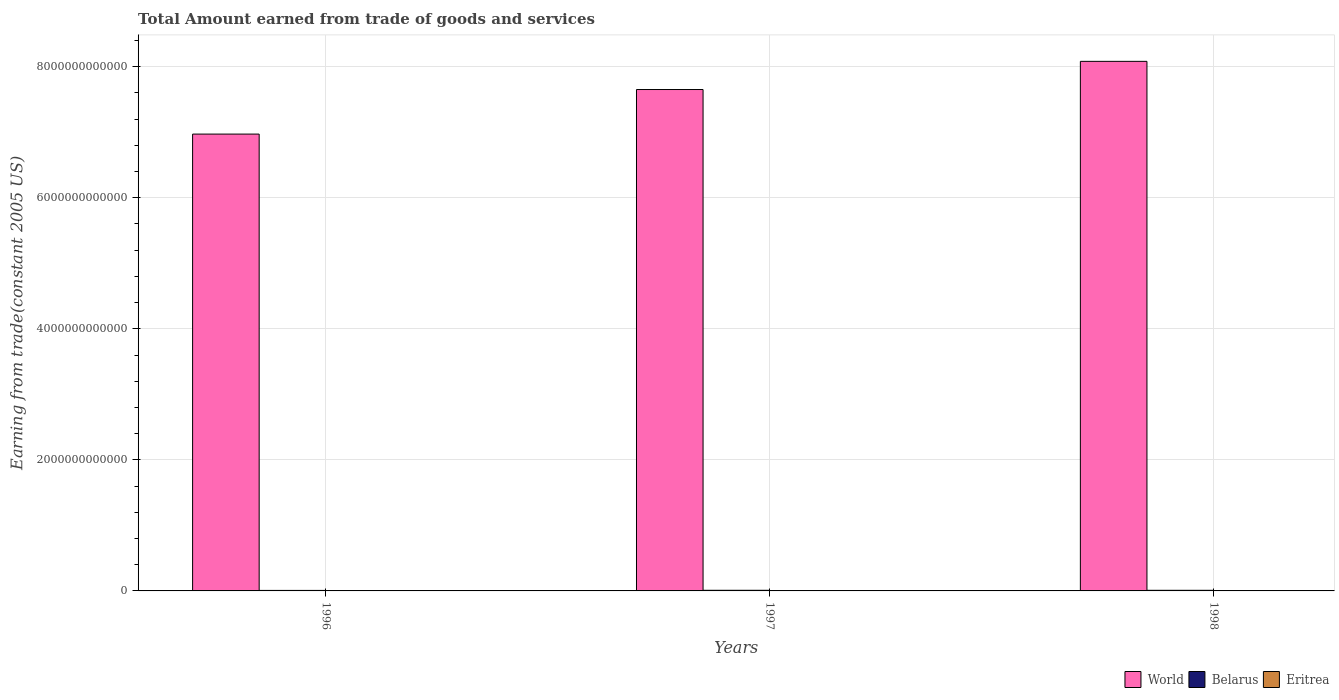How many different coloured bars are there?
Provide a short and direct response. 3. How many groups of bars are there?
Your answer should be compact. 3. Are the number of bars on each tick of the X-axis equal?
Ensure brevity in your answer.  Yes. How many bars are there on the 3rd tick from the left?
Offer a terse response. 3. How many bars are there on the 1st tick from the right?
Give a very brief answer. 3. What is the total amount earned by trading goods and services in Eritrea in 1998?
Offer a very short reply. 8.29e+08. Across all years, what is the maximum total amount earned by trading goods and services in Eritrea?
Your answer should be very brief. 8.29e+08. Across all years, what is the minimum total amount earned by trading goods and services in Belarus?
Your answer should be very brief. 7.64e+09. What is the total total amount earned by trading goods and services in Belarus in the graph?
Offer a terse response. 2.68e+1. What is the difference between the total amount earned by trading goods and services in Belarus in 1996 and that in 1998?
Make the answer very short. -1.84e+09. What is the difference between the total amount earned by trading goods and services in Belarus in 1997 and the total amount earned by trading goods and services in Eritrea in 1996?
Keep it short and to the point. 8.90e+09. What is the average total amount earned by trading goods and services in World per year?
Offer a very short reply. 7.57e+12. In the year 1997, what is the difference between the total amount earned by trading goods and services in World and total amount earned by trading goods and services in Belarus?
Your answer should be very brief. 7.64e+12. What is the ratio of the total amount earned by trading goods and services in World in 1997 to that in 1998?
Offer a very short reply. 0.95. Is the difference between the total amount earned by trading goods and services in World in 1997 and 1998 greater than the difference between the total amount earned by trading goods and services in Belarus in 1997 and 1998?
Offer a very short reply. No. What is the difference between the highest and the second highest total amount earned by trading goods and services in Belarus?
Provide a succinct answer. 1.84e+08. What is the difference between the highest and the lowest total amount earned by trading goods and services in Eritrea?
Provide a succinct answer. 6.05e+07. In how many years, is the total amount earned by trading goods and services in World greater than the average total amount earned by trading goods and services in World taken over all years?
Make the answer very short. 2. What does the 1st bar from the left in 1997 represents?
Give a very brief answer. World. What does the 2nd bar from the right in 1998 represents?
Provide a succinct answer. Belarus. Is it the case that in every year, the sum of the total amount earned by trading goods and services in Eritrea and total amount earned by trading goods and services in World is greater than the total amount earned by trading goods and services in Belarus?
Offer a very short reply. Yes. What is the difference between two consecutive major ticks on the Y-axis?
Your response must be concise. 2.00e+12. Does the graph contain any zero values?
Ensure brevity in your answer.  No. How are the legend labels stacked?
Provide a succinct answer. Horizontal. What is the title of the graph?
Provide a short and direct response. Total Amount earned from trade of goods and services. What is the label or title of the Y-axis?
Offer a very short reply. Earning from trade(constant 2005 US). What is the Earning from trade(constant 2005 US) of World in 1996?
Ensure brevity in your answer.  6.97e+12. What is the Earning from trade(constant 2005 US) of Belarus in 1996?
Your answer should be very brief. 7.64e+09. What is the Earning from trade(constant 2005 US) in Eritrea in 1996?
Provide a short and direct response. 7.69e+08. What is the Earning from trade(constant 2005 US) in World in 1997?
Offer a very short reply. 7.65e+12. What is the Earning from trade(constant 2005 US) in Belarus in 1997?
Ensure brevity in your answer.  9.66e+09. What is the Earning from trade(constant 2005 US) of Eritrea in 1997?
Keep it short and to the point. 7.87e+08. What is the Earning from trade(constant 2005 US) of World in 1998?
Offer a terse response. 8.08e+12. What is the Earning from trade(constant 2005 US) of Belarus in 1998?
Provide a short and direct response. 9.48e+09. What is the Earning from trade(constant 2005 US) of Eritrea in 1998?
Give a very brief answer. 8.29e+08. Across all years, what is the maximum Earning from trade(constant 2005 US) in World?
Offer a very short reply. 8.08e+12. Across all years, what is the maximum Earning from trade(constant 2005 US) in Belarus?
Provide a short and direct response. 9.66e+09. Across all years, what is the maximum Earning from trade(constant 2005 US) of Eritrea?
Your answer should be compact. 8.29e+08. Across all years, what is the minimum Earning from trade(constant 2005 US) of World?
Keep it short and to the point. 6.97e+12. Across all years, what is the minimum Earning from trade(constant 2005 US) of Belarus?
Give a very brief answer. 7.64e+09. Across all years, what is the minimum Earning from trade(constant 2005 US) of Eritrea?
Ensure brevity in your answer.  7.69e+08. What is the total Earning from trade(constant 2005 US) in World in the graph?
Give a very brief answer. 2.27e+13. What is the total Earning from trade(constant 2005 US) of Belarus in the graph?
Provide a succinct answer. 2.68e+1. What is the total Earning from trade(constant 2005 US) in Eritrea in the graph?
Provide a short and direct response. 2.39e+09. What is the difference between the Earning from trade(constant 2005 US) of World in 1996 and that in 1997?
Offer a very short reply. -6.80e+11. What is the difference between the Earning from trade(constant 2005 US) in Belarus in 1996 and that in 1997?
Ensure brevity in your answer.  -2.02e+09. What is the difference between the Earning from trade(constant 2005 US) of Eritrea in 1996 and that in 1997?
Your answer should be very brief. -1.86e+07. What is the difference between the Earning from trade(constant 2005 US) in World in 1996 and that in 1998?
Give a very brief answer. -1.11e+12. What is the difference between the Earning from trade(constant 2005 US) of Belarus in 1996 and that in 1998?
Your response must be concise. -1.84e+09. What is the difference between the Earning from trade(constant 2005 US) in Eritrea in 1996 and that in 1998?
Your answer should be very brief. -6.05e+07. What is the difference between the Earning from trade(constant 2005 US) in World in 1997 and that in 1998?
Offer a very short reply. -4.30e+11. What is the difference between the Earning from trade(constant 2005 US) in Belarus in 1997 and that in 1998?
Make the answer very short. 1.84e+08. What is the difference between the Earning from trade(constant 2005 US) in Eritrea in 1997 and that in 1998?
Give a very brief answer. -4.19e+07. What is the difference between the Earning from trade(constant 2005 US) in World in 1996 and the Earning from trade(constant 2005 US) in Belarus in 1997?
Your answer should be compact. 6.96e+12. What is the difference between the Earning from trade(constant 2005 US) of World in 1996 and the Earning from trade(constant 2005 US) of Eritrea in 1997?
Offer a very short reply. 6.97e+12. What is the difference between the Earning from trade(constant 2005 US) in Belarus in 1996 and the Earning from trade(constant 2005 US) in Eritrea in 1997?
Make the answer very short. 6.85e+09. What is the difference between the Earning from trade(constant 2005 US) in World in 1996 and the Earning from trade(constant 2005 US) in Belarus in 1998?
Keep it short and to the point. 6.96e+12. What is the difference between the Earning from trade(constant 2005 US) in World in 1996 and the Earning from trade(constant 2005 US) in Eritrea in 1998?
Provide a succinct answer. 6.97e+12. What is the difference between the Earning from trade(constant 2005 US) of Belarus in 1996 and the Earning from trade(constant 2005 US) of Eritrea in 1998?
Your response must be concise. 6.81e+09. What is the difference between the Earning from trade(constant 2005 US) of World in 1997 and the Earning from trade(constant 2005 US) of Belarus in 1998?
Offer a very short reply. 7.64e+12. What is the difference between the Earning from trade(constant 2005 US) in World in 1997 and the Earning from trade(constant 2005 US) in Eritrea in 1998?
Provide a short and direct response. 7.65e+12. What is the difference between the Earning from trade(constant 2005 US) of Belarus in 1997 and the Earning from trade(constant 2005 US) of Eritrea in 1998?
Give a very brief answer. 8.83e+09. What is the average Earning from trade(constant 2005 US) in World per year?
Your response must be concise. 7.57e+12. What is the average Earning from trade(constant 2005 US) in Belarus per year?
Your response must be concise. 8.93e+09. What is the average Earning from trade(constant 2005 US) in Eritrea per year?
Make the answer very short. 7.95e+08. In the year 1996, what is the difference between the Earning from trade(constant 2005 US) in World and Earning from trade(constant 2005 US) in Belarus?
Your answer should be very brief. 6.96e+12. In the year 1996, what is the difference between the Earning from trade(constant 2005 US) in World and Earning from trade(constant 2005 US) in Eritrea?
Offer a very short reply. 6.97e+12. In the year 1996, what is the difference between the Earning from trade(constant 2005 US) in Belarus and Earning from trade(constant 2005 US) in Eritrea?
Provide a succinct answer. 6.87e+09. In the year 1997, what is the difference between the Earning from trade(constant 2005 US) of World and Earning from trade(constant 2005 US) of Belarus?
Keep it short and to the point. 7.64e+12. In the year 1997, what is the difference between the Earning from trade(constant 2005 US) of World and Earning from trade(constant 2005 US) of Eritrea?
Offer a terse response. 7.65e+12. In the year 1997, what is the difference between the Earning from trade(constant 2005 US) in Belarus and Earning from trade(constant 2005 US) in Eritrea?
Provide a succinct answer. 8.88e+09. In the year 1998, what is the difference between the Earning from trade(constant 2005 US) in World and Earning from trade(constant 2005 US) in Belarus?
Ensure brevity in your answer.  8.07e+12. In the year 1998, what is the difference between the Earning from trade(constant 2005 US) of World and Earning from trade(constant 2005 US) of Eritrea?
Your response must be concise. 8.08e+12. In the year 1998, what is the difference between the Earning from trade(constant 2005 US) in Belarus and Earning from trade(constant 2005 US) in Eritrea?
Give a very brief answer. 8.65e+09. What is the ratio of the Earning from trade(constant 2005 US) in World in 1996 to that in 1997?
Your answer should be very brief. 0.91. What is the ratio of the Earning from trade(constant 2005 US) in Belarus in 1996 to that in 1997?
Make the answer very short. 0.79. What is the ratio of the Earning from trade(constant 2005 US) of Eritrea in 1996 to that in 1997?
Your response must be concise. 0.98. What is the ratio of the Earning from trade(constant 2005 US) in World in 1996 to that in 1998?
Give a very brief answer. 0.86. What is the ratio of the Earning from trade(constant 2005 US) in Belarus in 1996 to that in 1998?
Your answer should be compact. 0.81. What is the ratio of the Earning from trade(constant 2005 US) in Eritrea in 1996 to that in 1998?
Your answer should be compact. 0.93. What is the ratio of the Earning from trade(constant 2005 US) of World in 1997 to that in 1998?
Your response must be concise. 0.95. What is the ratio of the Earning from trade(constant 2005 US) of Belarus in 1997 to that in 1998?
Give a very brief answer. 1.02. What is the ratio of the Earning from trade(constant 2005 US) in Eritrea in 1997 to that in 1998?
Give a very brief answer. 0.95. What is the difference between the highest and the second highest Earning from trade(constant 2005 US) of World?
Keep it short and to the point. 4.30e+11. What is the difference between the highest and the second highest Earning from trade(constant 2005 US) of Belarus?
Offer a very short reply. 1.84e+08. What is the difference between the highest and the second highest Earning from trade(constant 2005 US) of Eritrea?
Ensure brevity in your answer.  4.19e+07. What is the difference between the highest and the lowest Earning from trade(constant 2005 US) in World?
Offer a very short reply. 1.11e+12. What is the difference between the highest and the lowest Earning from trade(constant 2005 US) of Belarus?
Your answer should be very brief. 2.02e+09. What is the difference between the highest and the lowest Earning from trade(constant 2005 US) in Eritrea?
Give a very brief answer. 6.05e+07. 